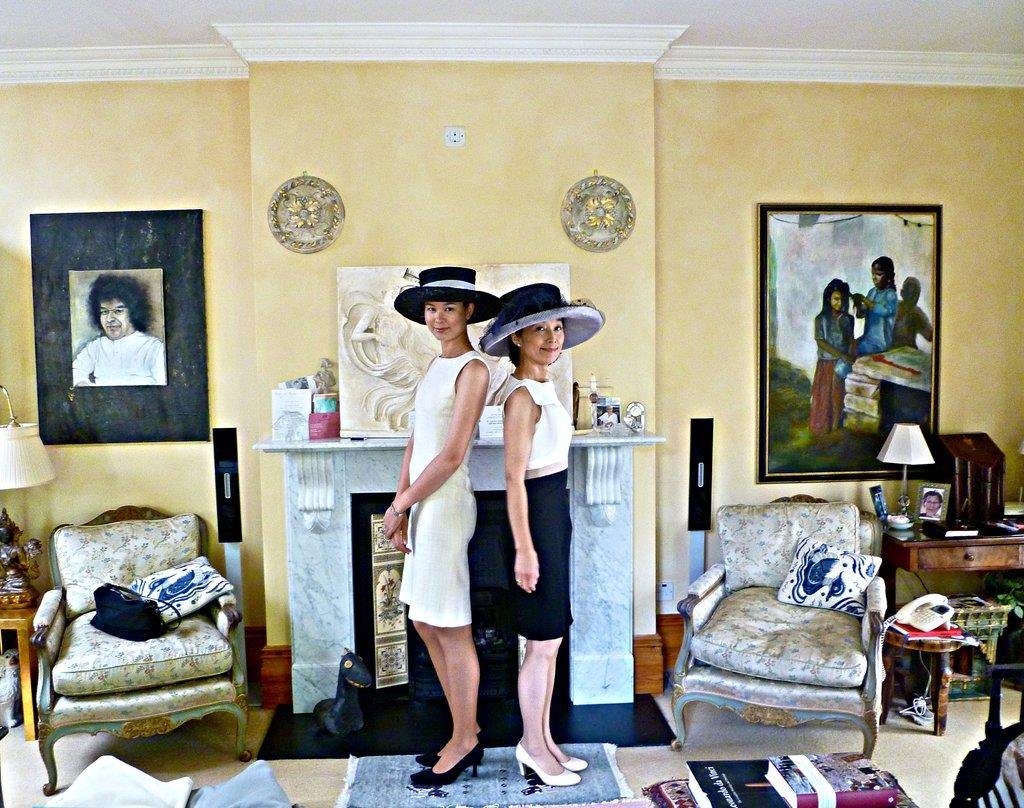How many women are in the room? There are two women in the room. What are the women wearing on their heads? The women are wearing hats. What type of furniture can be found in the room? There are chairs and tables in the room. What decorative items are on the wall? There are photo frames on the wall. How many lamps are in the room? There are two lamps in the room. What type of communication device is in the room? There is a landline phone in the room. What type of reading material is in the room? There is a book in the room. What type of ice treatment is being applied to the women's hats in the room? There is no ice or treatment being applied to the women's hats in the room; they are simply wearing them. What type of suit is hanging in the room? There is no suit present in the room. 